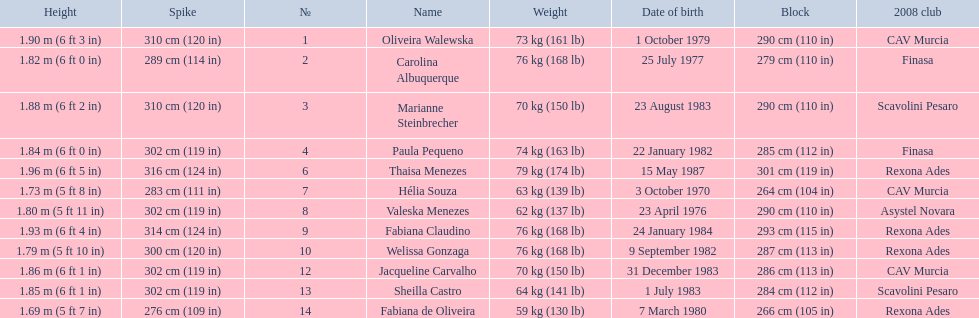What are the heights of the players? 1.90 m (6 ft 3 in), 1.82 m (6 ft 0 in), 1.88 m (6 ft 2 in), 1.84 m (6 ft 0 in), 1.96 m (6 ft 5 in), 1.73 m (5 ft 8 in), 1.80 m (5 ft 11 in), 1.93 m (6 ft 4 in), 1.79 m (5 ft 10 in), 1.86 m (6 ft 1 in), 1.85 m (6 ft 1 in), 1.69 m (5 ft 7 in). Which of these heights is the shortest? 1.69 m (5 ft 7 in). Which player is 5'7 tall? Fabiana de Oliveira. 